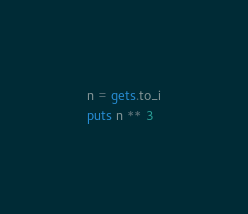<code> <loc_0><loc_0><loc_500><loc_500><_Ruby_>n = gets.to_i
puts n ** 3</code> 